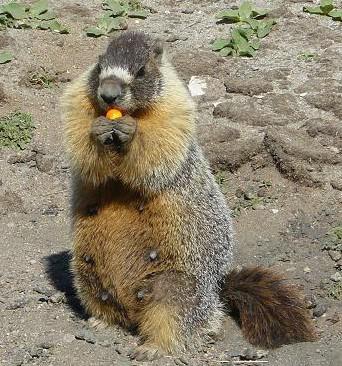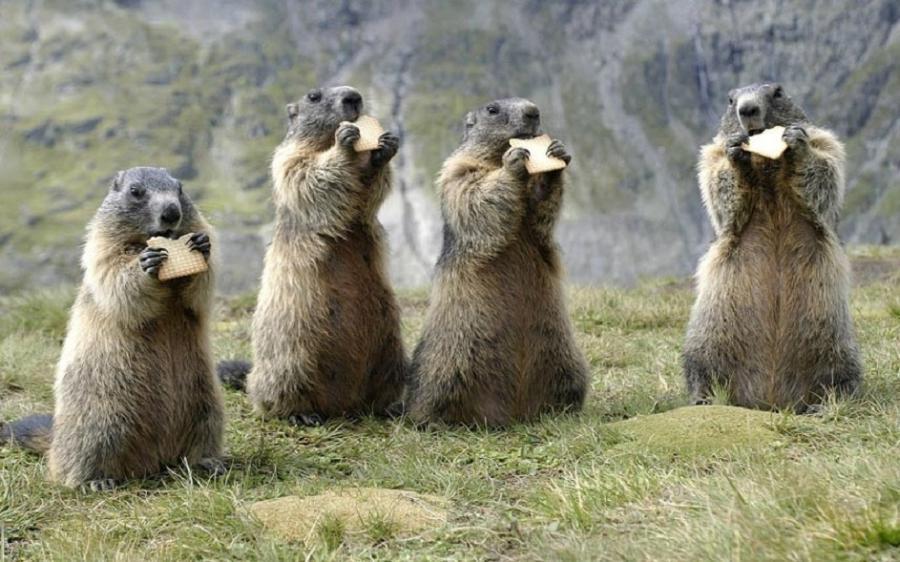The first image is the image on the left, the second image is the image on the right. Analyze the images presented: Is the assertion "An image shows a row of four prairie dog type animals, standing upright eating crackers." valid? Answer yes or no. Yes. 